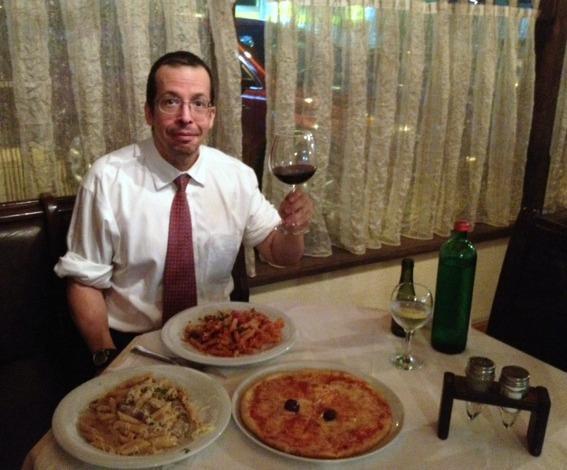Verify the accuracy of this image caption: "The person is away from the pizza.".
Answer yes or no. Yes. 